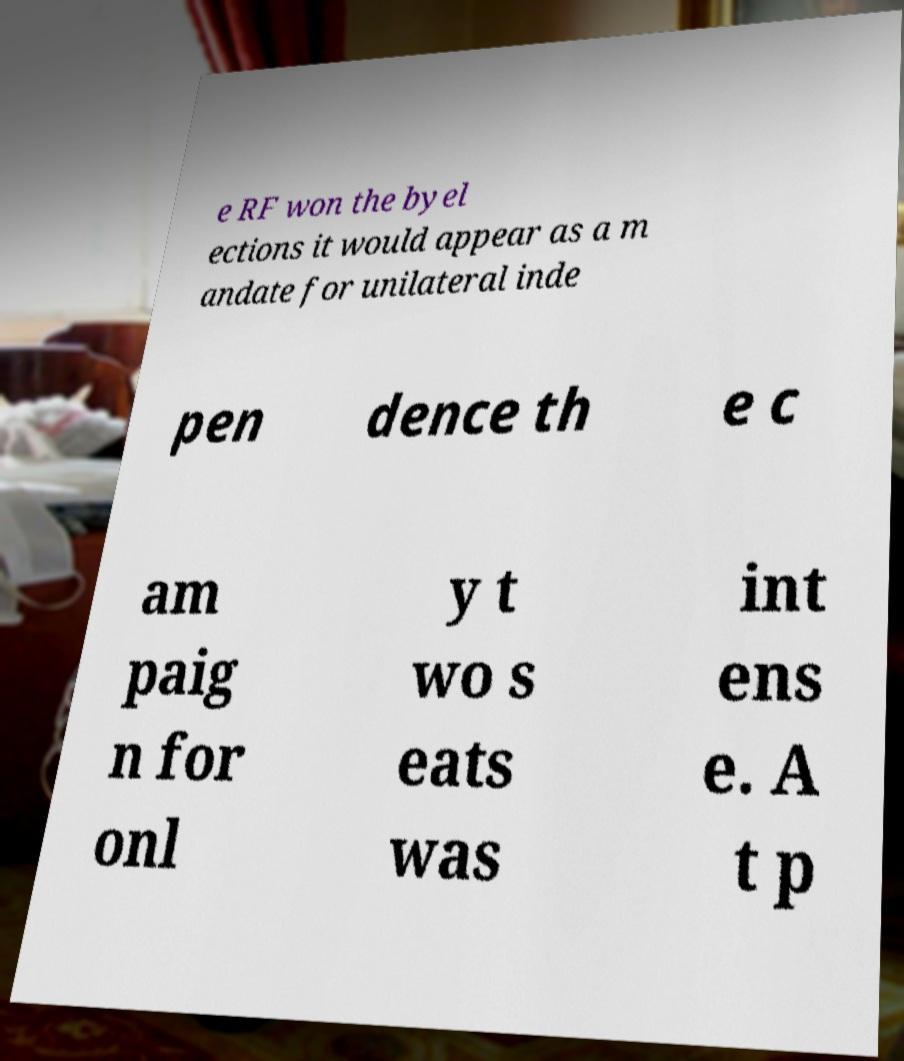I need the written content from this picture converted into text. Can you do that? e RF won the byel ections it would appear as a m andate for unilateral inde pen dence th e c am paig n for onl y t wo s eats was int ens e. A t p 